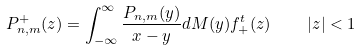Convert formula to latex. <formula><loc_0><loc_0><loc_500><loc_500>P ^ { + } _ { n , m } ( z ) = \int _ { - \infty } ^ { \infty } \frac { P _ { n , m } ( y ) } { x - y } d M ( y ) f ^ { t } _ { + } ( z ) \quad | z | < 1</formula> 